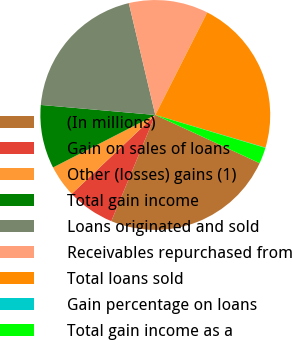Convert chart to OTSL. <chart><loc_0><loc_0><loc_500><loc_500><pie_chart><fcel>(In millions)<fcel>Gain on sales of loans<fcel>Other (losses) gains (1)<fcel>Total gain income<fcel>Loans originated and sold<fcel>Receivables repurchased from<fcel>Total loans sold<fcel>Gain percentage on loans<fcel>Total gain income as a<nl><fcel>24.36%<fcel>6.71%<fcel>4.49%<fcel>8.94%<fcel>19.91%<fcel>11.16%<fcel>22.13%<fcel>0.04%<fcel>2.26%<nl></chart> 